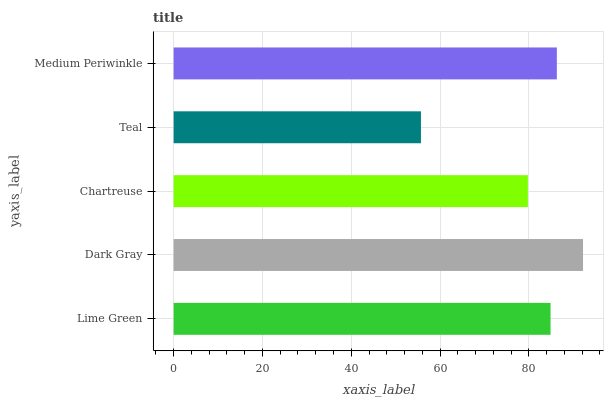Is Teal the minimum?
Answer yes or no. Yes. Is Dark Gray the maximum?
Answer yes or no. Yes. Is Chartreuse the minimum?
Answer yes or no. No. Is Chartreuse the maximum?
Answer yes or no. No. Is Dark Gray greater than Chartreuse?
Answer yes or no. Yes. Is Chartreuse less than Dark Gray?
Answer yes or no. Yes. Is Chartreuse greater than Dark Gray?
Answer yes or no. No. Is Dark Gray less than Chartreuse?
Answer yes or no. No. Is Lime Green the high median?
Answer yes or no. Yes. Is Lime Green the low median?
Answer yes or no. Yes. Is Teal the high median?
Answer yes or no. No. Is Teal the low median?
Answer yes or no. No. 